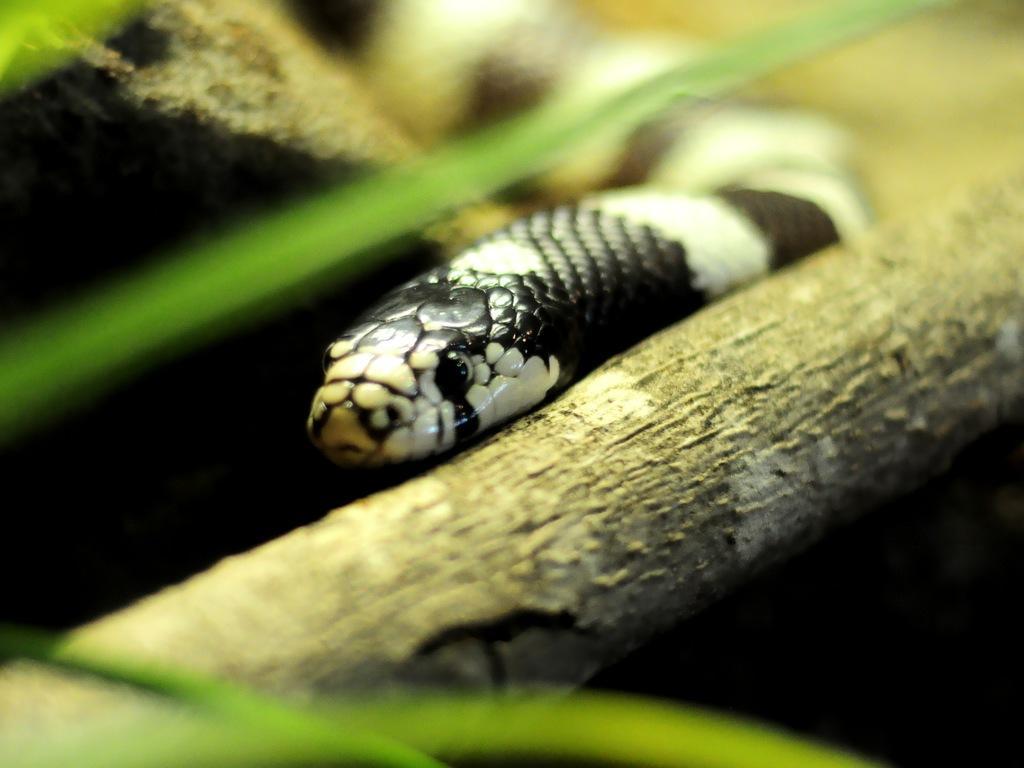How would you summarize this image in a sentence or two? In the center of the image a snake is there. In the background of the image we can see branch, leaves are present. 